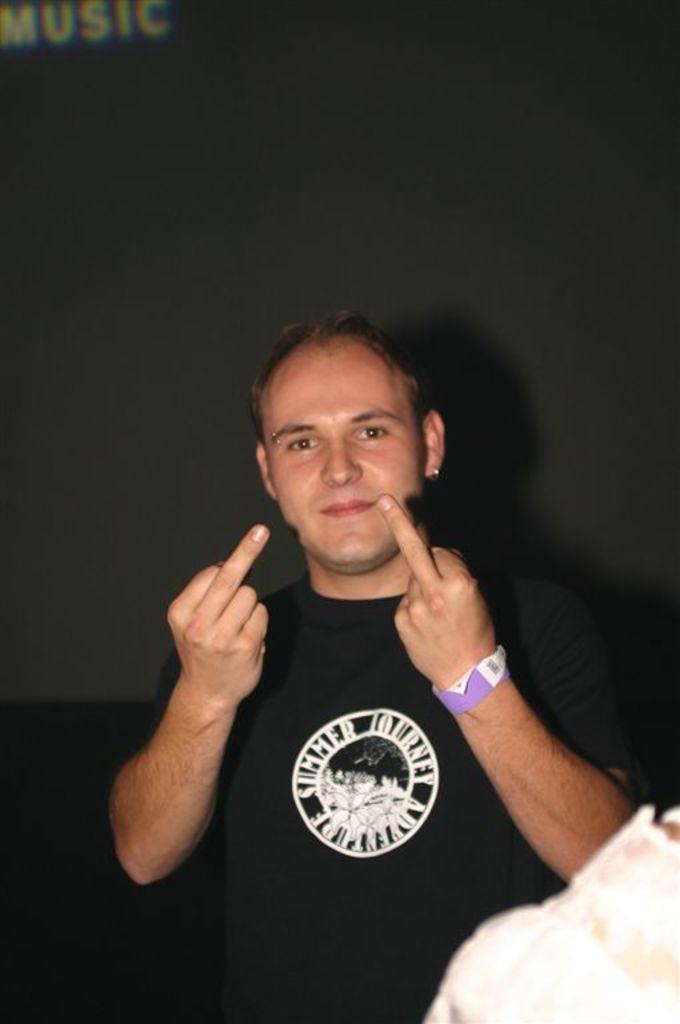Describe this image in one or two sentences. In this picture there is a man wearing black color t-shirt standing in the front, smiling and giving a pose to the camera. Behind there is dark background. 